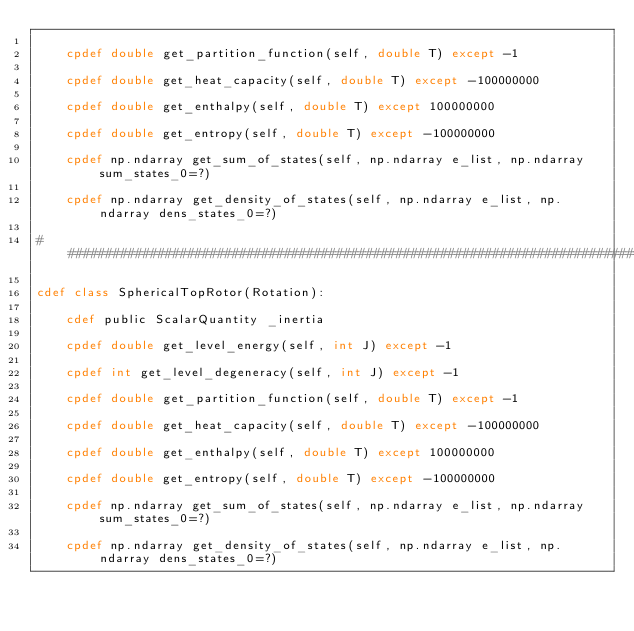Convert code to text. <code><loc_0><loc_0><loc_500><loc_500><_Cython_>
    cpdef double get_partition_function(self, double T) except -1

    cpdef double get_heat_capacity(self, double T) except -100000000

    cpdef double get_enthalpy(self, double T) except 100000000

    cpdef double get_entropy(self, double T) except -100000000

    cpdef np.ndarray get_sum_of_states(self, np.ndarray e_list, np.ndarray sum_states_0=?)

    cpdef np.ndarray get_density_of_states(self, np.ndarray e_list, np.ndarray dens_states_0=?)

################################################################################

cdef class SphericalTopRotor(Rotation):

    cdef public ScalarQuantity _inertia

    cpdef double get_level_energy(self, int J) except -1
    
    cpdef int get_level_degeneracy(self, int J) except -1
    
    cpdef double get_partition_function(self, double T) except -1
    
    cpdef double get_heat_capacity(self, double T) except -100000000

    cpdef double get_enthalpy(self, double T) except 100000000

    cpdef double get_entropy(self, double T) except -100000000

    cpdef np.ndarray get_sum_of_states(self, np.ndarray e_list, np.ndarray sum_states_0=?)
    
    cpdef np.ndarray get_density_of_states(self, np.ndarray e_list, np.ndarray dens_states_0=?)
</code> 